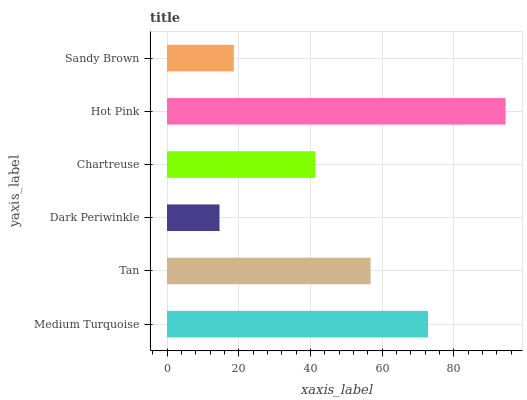Is Dark Periwinkle the minimum?
Answer yes or no. Yes. Is Hot Pink the maximum?
Answer yes or no. Yes. Is Tan the minimum?
Answer yes or no. No. Is Tan the maximum?
Answer yes or no. No. Is Medium Turquoise greater than Tan?
Answer yes or no. Yes. Is Tan less than Medium Turquoise?
Answer yes or no. Yes. Is Tan greater than Medium Turquoise?
Answer yes or no. No. Is Medium Turquoise less than Tan?
Answer yes or no. No. Is Tan the high median?
Answer yes or no. Yes. Is Chartreuse the low median?
Answer yes or no. Yes. Is Medium Turquoise the high median?
Answer yes or no. No. Is Dark Periwinkle the low median?
Answer yes or no. No. 